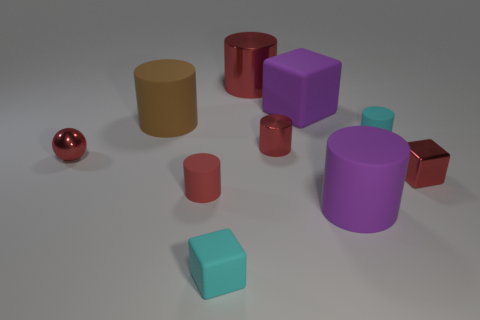Is the shape of the brown rubber object the same as the red rubber thing?
Give a very brief answer. Yes. Is there a large brown cylinder that has the same material as the cyan cylinder?
Offer a terse response. Yes. Are there any things that are in front of the tiny cyan thing that is behind the red metallic block?
Ensure brevity in your answer.  Yes. Does the cylinder that is behind the brown thing have the same size as the brown object?
Your answer should be very brief. Yes. How big is the shiny ball?
Your response must be concise. Small. Is there a large matte cube of the same color as the big metallic thing?
Your answer should be compact. No. How many tiny objects are blue metal spheres or purple rubber objects?
Give a very brief answer. 0. What is the size of the cube that is both right of the cyan rubber block and in front of the small cyan matte cylinder?
Offer a terse response. Small. There is a tiny red block; how many cyan matte things are in front of it?
Make the answer very short. 1. What shape is the big matte thing that is right of the large brown cylinder and behind the small metallic cylinder?
Your response must be concise. Cube. 